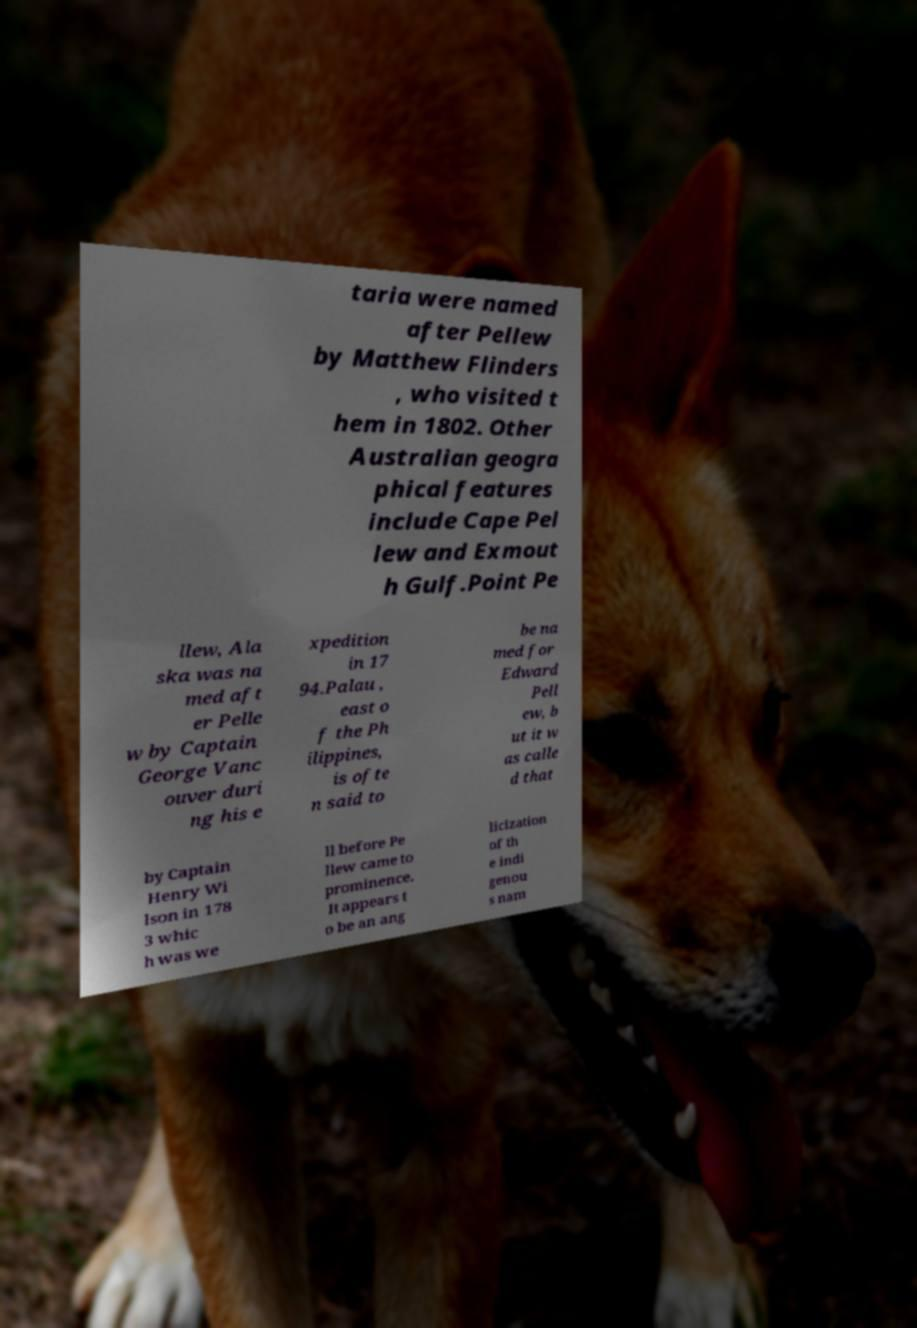I need the written content from this picture converted into text. Can you do that? taria were named after Pellew by Matthew Flinders , who visited t hem in 1802. Other Australian geogra phical features include Cape Pel lew and Exmout h Gulf.Point Pe llew, Ala ska was na med aft er Pelle w by Captain George Vanc ouver duri ng his e xpedition in 17 94.Palau , east o f the Ph ilippines, is ofte n said to be na med for Edward Pell ew, b ut it w as calle d that by Captain Henry Wi lson in 178 3 whic h was we ll before Pe llew came to prominence. It appears t o be an ang licization of th e indi genou s nam 